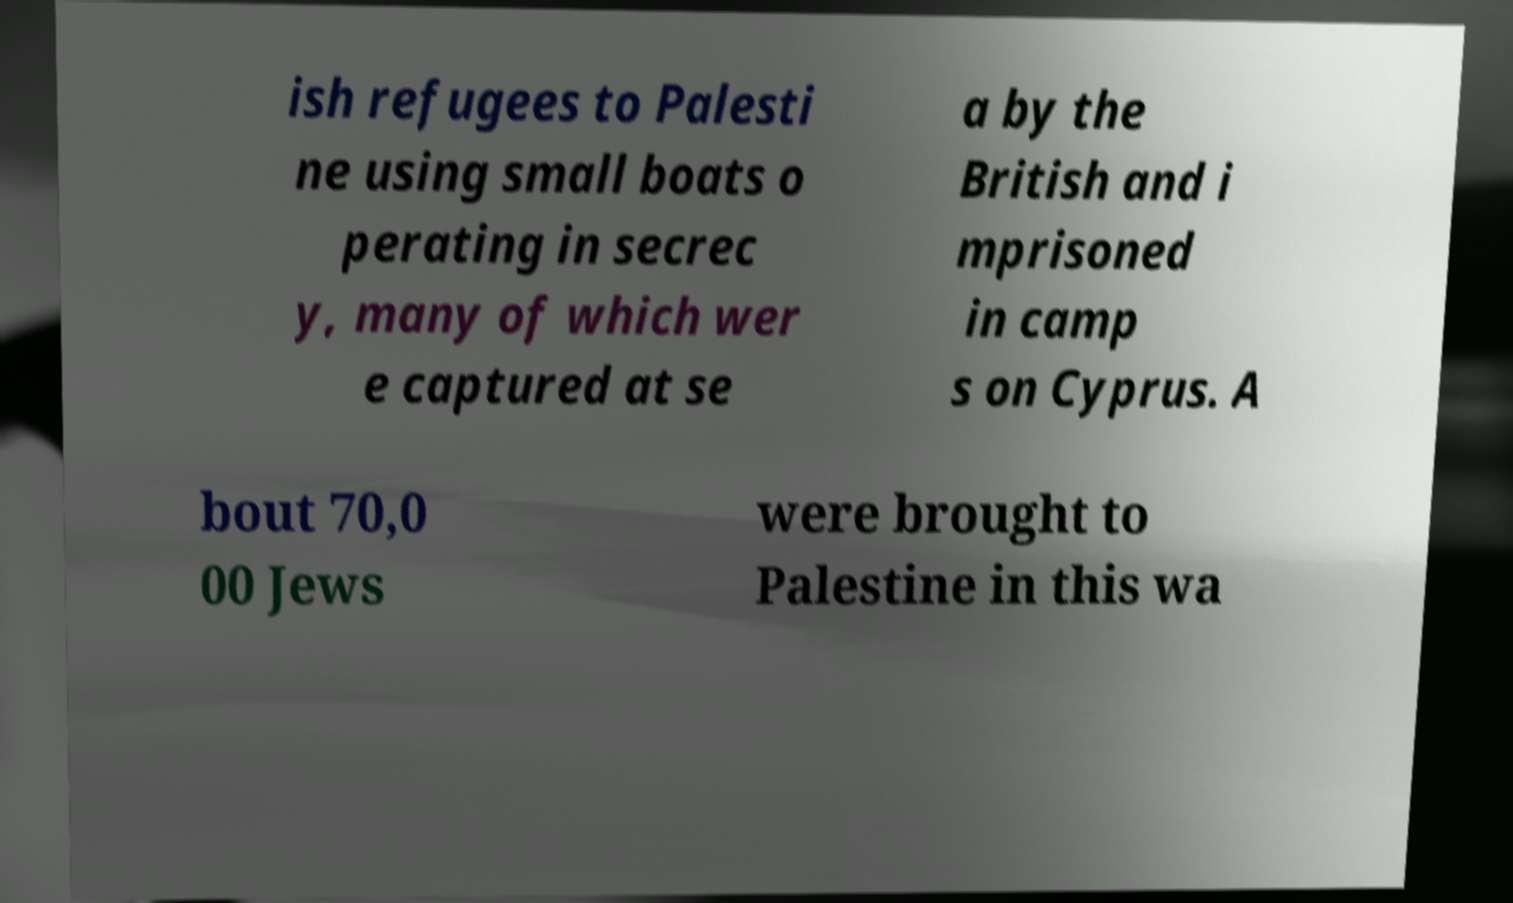Can you read and provide the text displayed in the image?This photo seems to have some interesting text. Can you extract and type it out for me? ish refugees to Palesti ne using small boats o perating in secrec y, many of which wer e captured at se a by the British and i mprisoned in camp s on Cyprus. A bout 70,0 00 Jews were brought to Palestine in this wa 